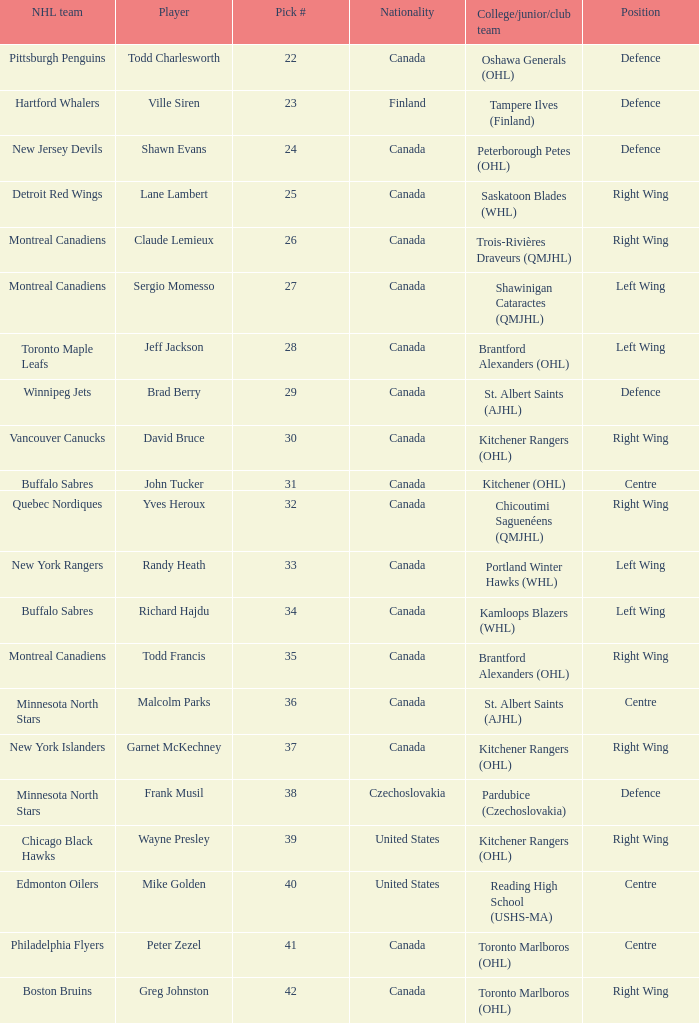What is the position for the nhl team toronto maple leafs? Left Wing. 